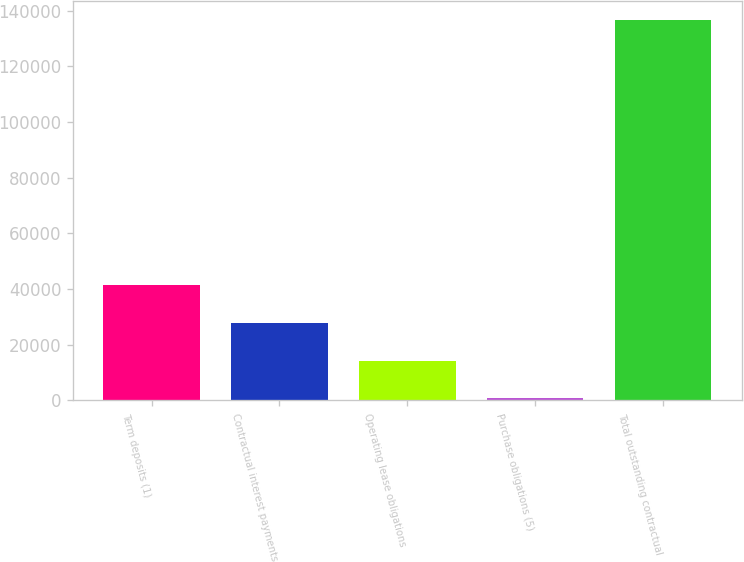<chart> <loc_0><loc_0><loc_500><loc_500><bar_chart><fcel>Term deposits (1)<fcel>Contractual interest payments<fcel>Operating lease obligations<fcel>Purchase obligations (5)<fcel>Total outstanding contractual<nl><fcel>41527.4<fcel>27926.6<fcel>14325.8<fcel>725<fcel>136733<nl></chart> 